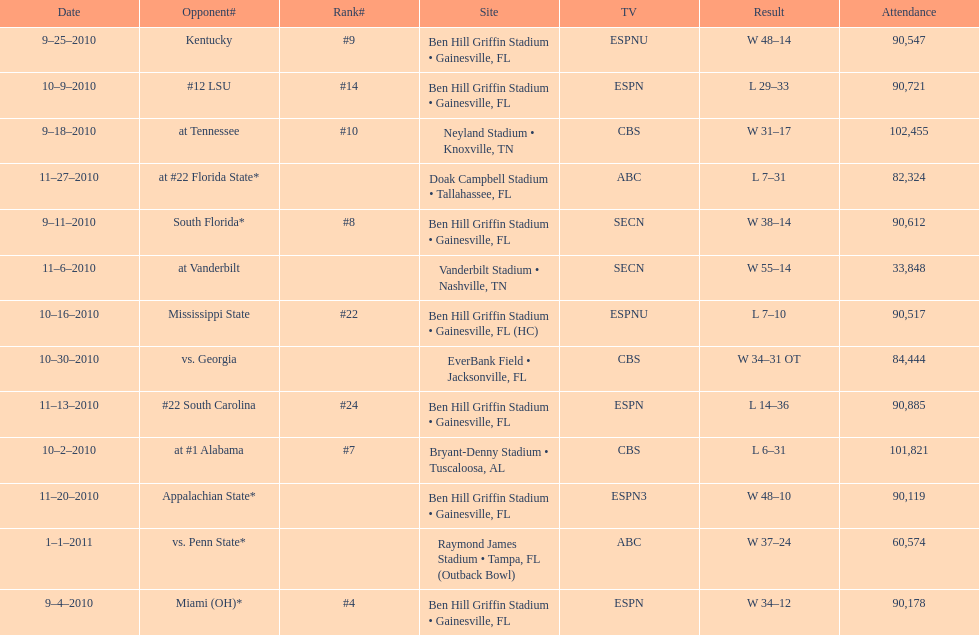The gators won the game on september 25, 2010. who won the previous game? Gators. 